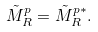<formula> <loc_0><loc_0><loc_500><loc_500>\tilde { M } _ { R } ^ { p } = \tilde { M } _ { R } ^ { p \ast } .</formula> 